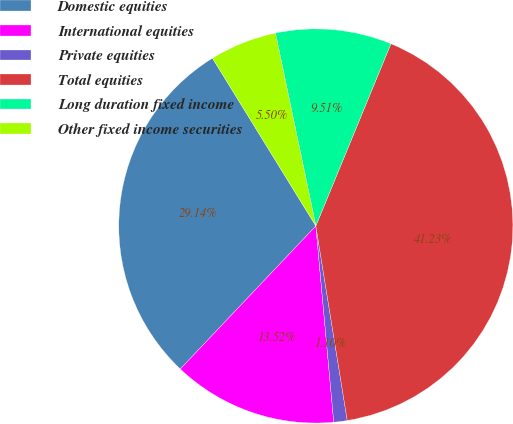<chart> <loc_0><loc_0><loc_500><loc_500><pie_chart><fcel>Domestic equities<fcel>International equities<fcel>Private equities<fcel>Total equities<fcel>Long duration fixed income<fcel>Other fixed income securities<nl><fcel>29.14%<fcel>13.52%<fcel>1.1%<fcel>41.23%<fcel>9.51%<fcel>5.5%<nl></chart> 